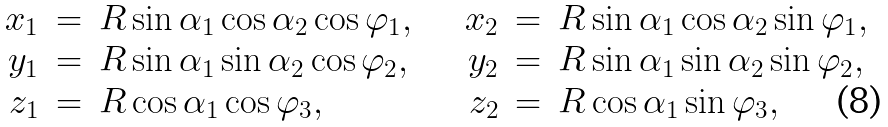<formula> <loc_0><loc_0><loc_500><loc_500>\begin{array} { r c l } x _ { 1 } & = & R \sin \alpha _ { 1 } \cos \alpha _ { 2 } \cos \varphi _ { 1 } , \\ y _ { 1 } & = & R \sin \alpha _ { 1 } \sin \alpha _ { 2 } \cos \varphi _ { 2 } , \\ z _ { 1 } & = & R \cos \alpha _ { 1 } \cos \varphi _ { 3 } , \end{array} \quad \begin{array} { r c l } x _ { 2 } & = & R \sin \alpha _ { 1 } \cos \alpha _ { 2 } \sin \varphi _ { 1 } , \\ y _ { 2 } & = & R \sin \alpha _ { 1 } \sin \alpha _ { 2 } \sin \varphi _ { 2 } , \\ z _ { 2 } & = & R \cos \alpha _ { 1 } \sin \varphi _ { 3 } , \end{array}</formula> 